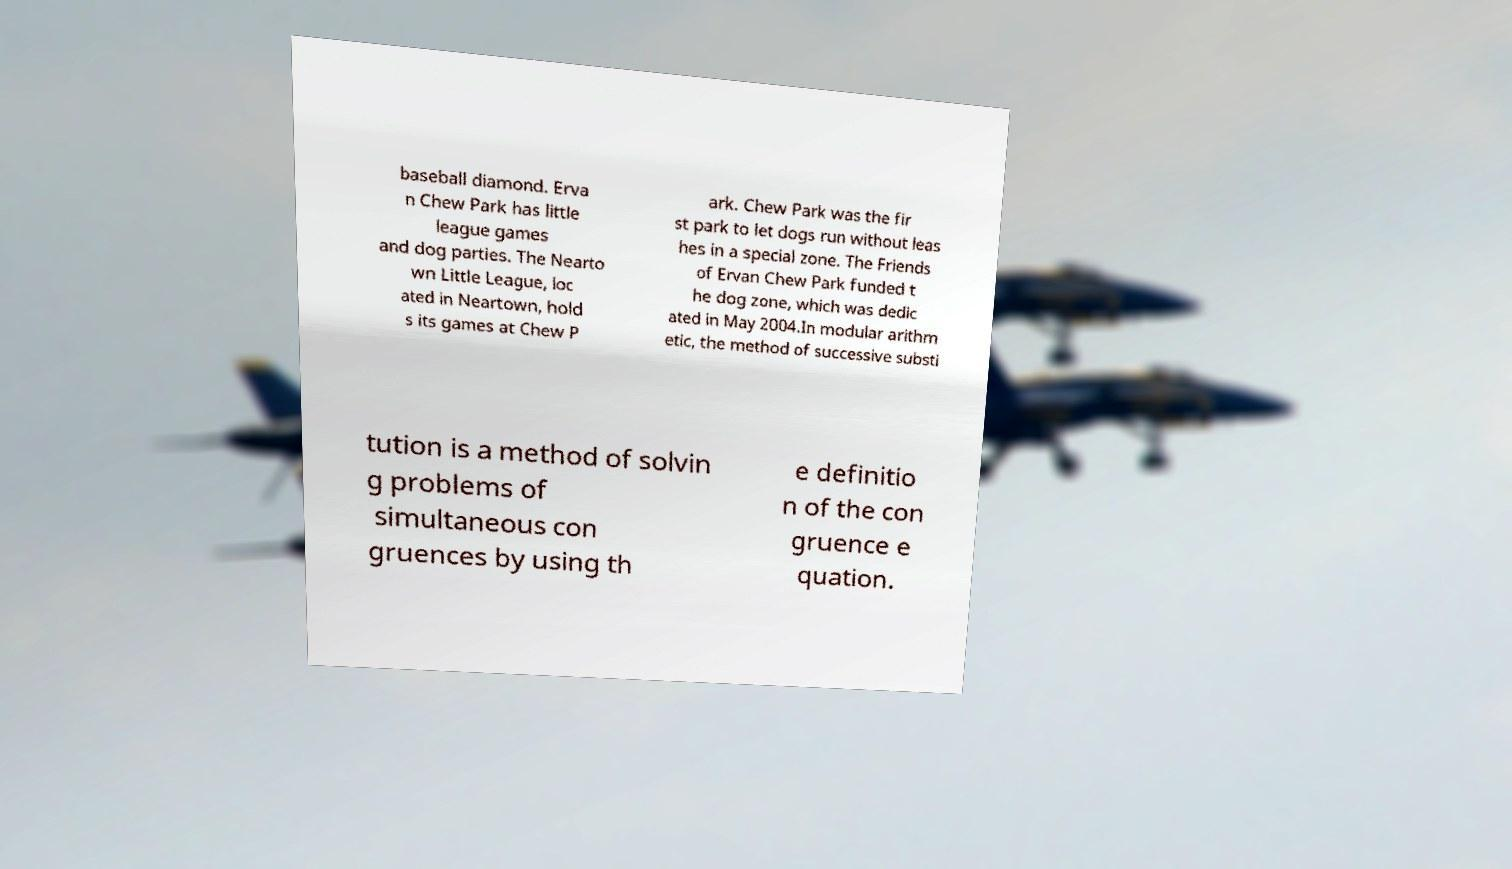There's text embedded in this image that I need extracted. Can you transcribe it verbatim? baseball diamond. Erva n Chew Park has little league games and dog parties. The Nearto wn Little League, loc ated in Neartown, hold s its games at Chew P ark. Chew Park was the fir st park to let dogs run without leas hes in a special zone. The Friends of Ervan Chew Park funded t he dog zone, which was dedic ated in May 2004.In modular arithm etic, the method of successive substi tution is a method of solvin g problems of simultaneous con gruences by using th e definitio n of the con gruence e quation. 